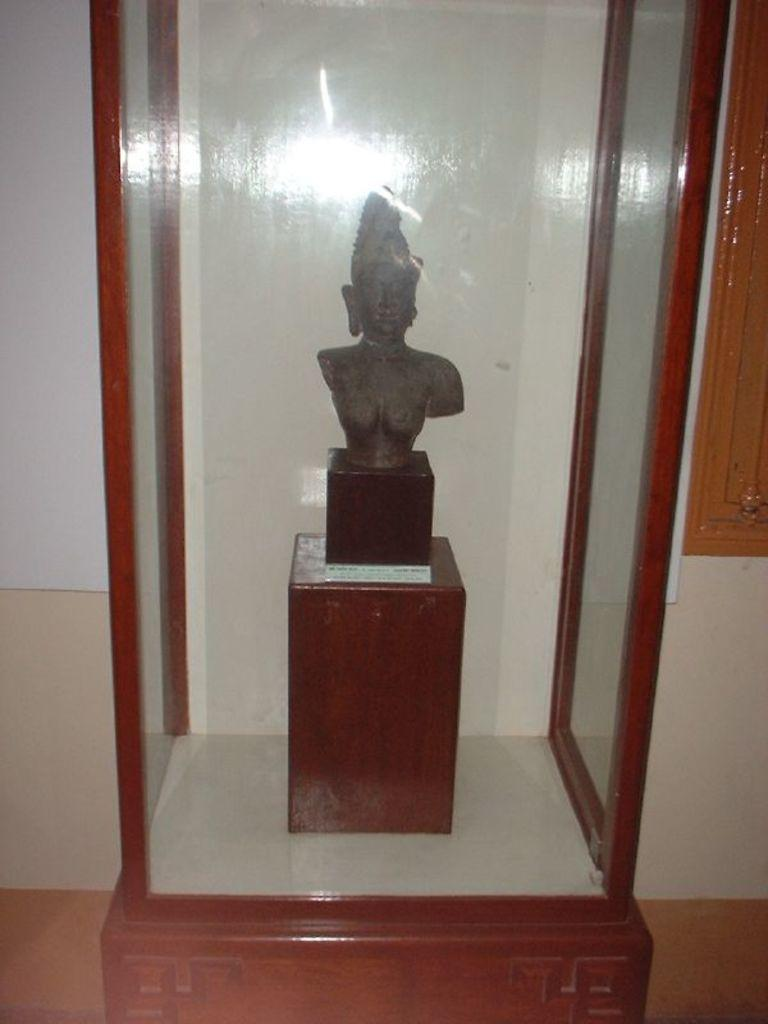What is the main subject of the image? The main subject of the image is a sculpture on a stand. How is the sculpture protected or displayed? The sculpture is inside a glass container. What can be seen in the background of the image? There is a wall visible in the image. What type of grass is growing near the sculpture in the image? There is no grass visible in the image; the sculpture is inside a glass container. What relation does the sculpture have to the wall in the image? The sculpture and the wall are separate objects in the image, and no relation between them is implied. 